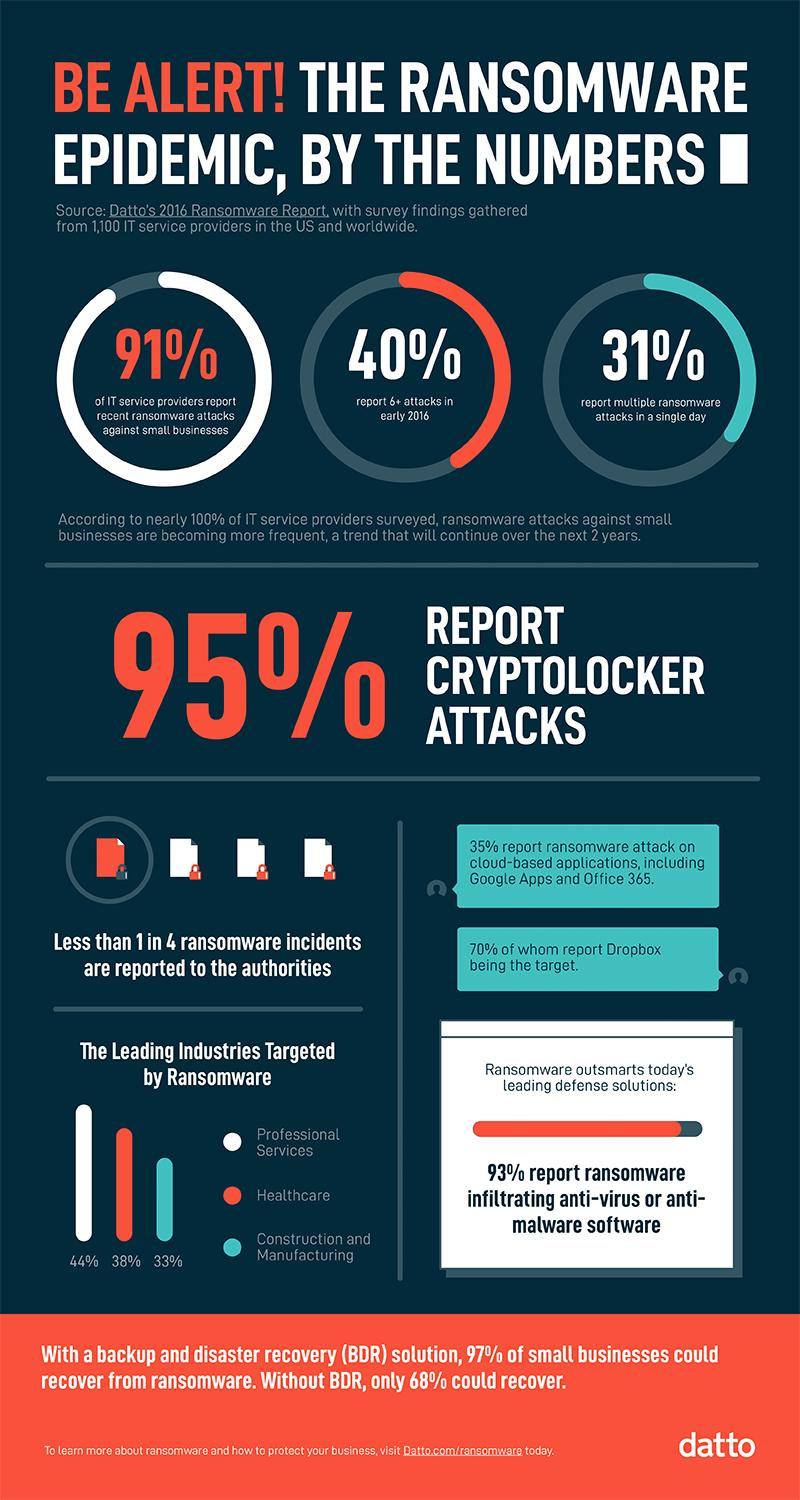Give some essential details in this illustration. According to recent data, a significant majority of professional services and healthcare organizations are targeted by ransomware, collectively representing 82% of affected organizations. A recent study found that ransomware targets have been prevalent in the healthcare, construction, and manufacturing industries, accounting for a collective 71% of all targeted sectors. According to a recent survey, only 5% of individuals who experienced a cyberlocker attack reported it to the appropriate authorities. According to a report, a staggering 91% of small businesses have been targeted by ransomware attacks. According to a recent study, 44% of professional services are targeted by ransomware. 